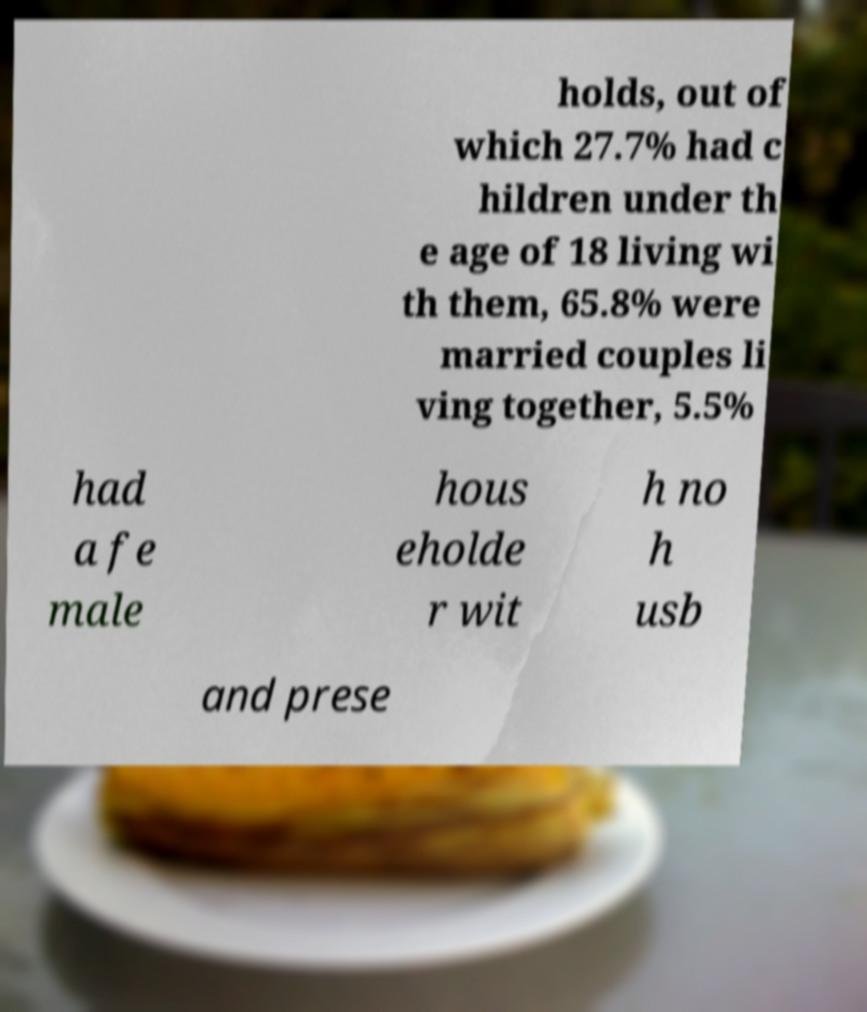Please read and relay the text visible in this image. What does it say? holds, out of which 27.7% had c hildren under th e age of 18 living wi th them, 65.8% were married couples li ving together, 5.5% had a fe male hous eholde r wit h no h usb and prese 